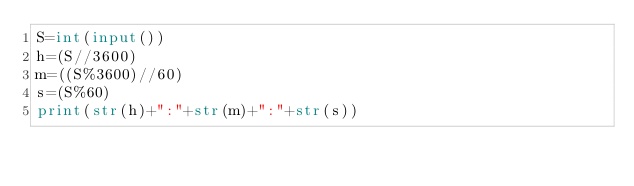Convert code to text. <code><loc_0><loc_0><loc_500><loc_500><_Python_>S=int(input())
h=(S//3600)
m=((S%3600)//60)
s=(S%60)
print(str(h)+":"+str(m)+":"+str(s))
</code> 